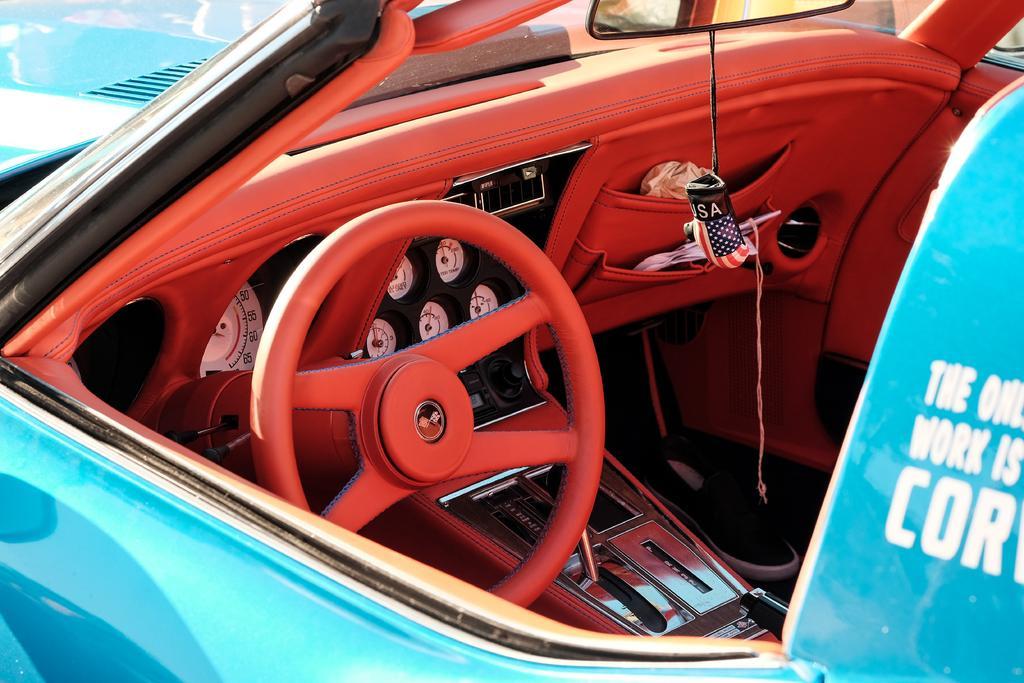Please provide a concise description of this image. In this image, we can see there is a blue color vehicle, on which there are white color texts. This vehicle has had side door, which is having a window. Through this window, we can see there is a steering wheel, speedometers, a front mirror and other objects. 